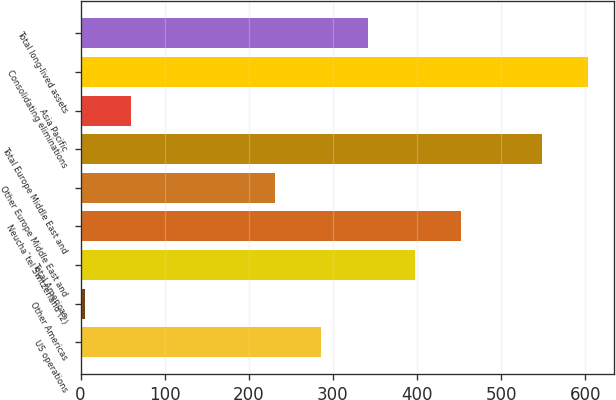Convert chart to OTSL. <chart><loc_0><loc_0><loc_500><loc_500><bar_chart><fcel>US operations<fcel>Other Americas<fcel>Total Americas<fcel>Neuchaˆtel Switzerland (2)<fcel>Other Europe Middle East and<fcel>Total Europe Middle East and<fcel>Asia Pacific<fcel>Consolidating eliminations<fcel>Total long-lived assets<nl><fcel>286.17<fcel>5<fcel>397.11<fcel>452.58<fcel>230.7<fcel>548.2<fcel>60.47<fcel>603.67<fcel>341.64<nl></chart> 